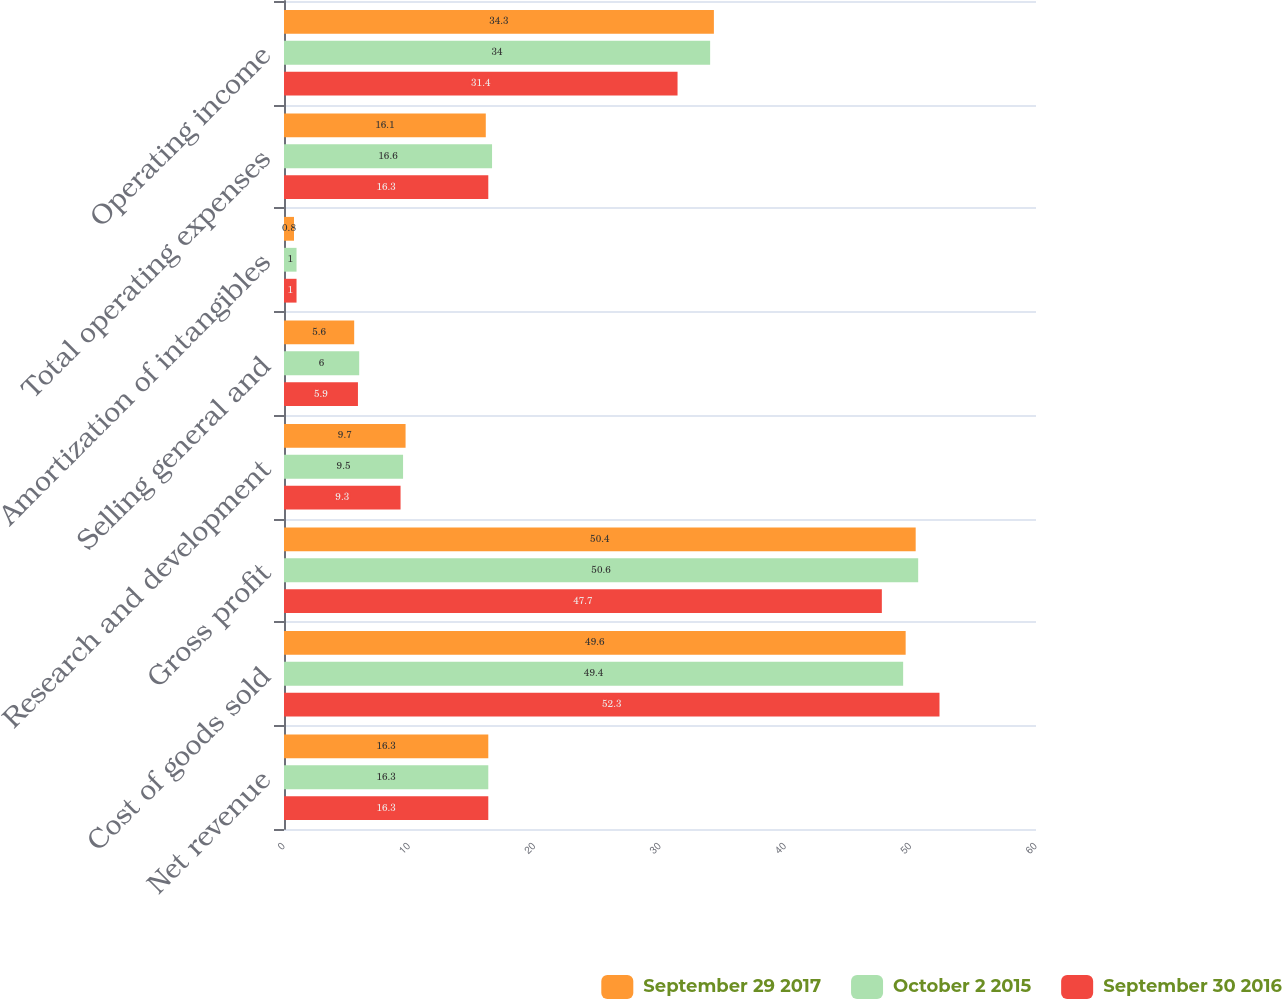Convert chart. <chart><loc_0><loc_0><loc_500><loc_500><stacked_bar_chart><ecel><fcel>Net revenue<fcel>Cost of goods sold<fcel>Gross profit<fcel>Research and development<fcel>Selling general and<fcel>Amortization of intangibles<fcel>Total operating expenses<fcel>Operating income<nl><fcel>September 29 2017<fcel>16.3<fcel>49.6<fcel>50.4<fcel>9.7<fcel>5.6<fcel>0.8<fcel>16.1<fcel>34.3<nl><fcel>October 2 2015<fcel>16.3<fcel>49.4<fcel>50.6<fcel>9.5<fcel>6<fcel>1<fcel>16.6<fcel>34<nl><fcel>September 30 2016<fcel>16.3<fcel>52.3<fcel>47.7<fcel>9.3<fcel>5.9<fcel>1<fcel>16.3<fcel>31.4<nl></chart> 